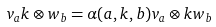<formula> <loc_0><loc_0><loc_500><loc_500>v _ { a } k \otimes w _ { b } = \alpha ( a , k , b ) v _ { a } \otimes k w _ { b }</formula> 